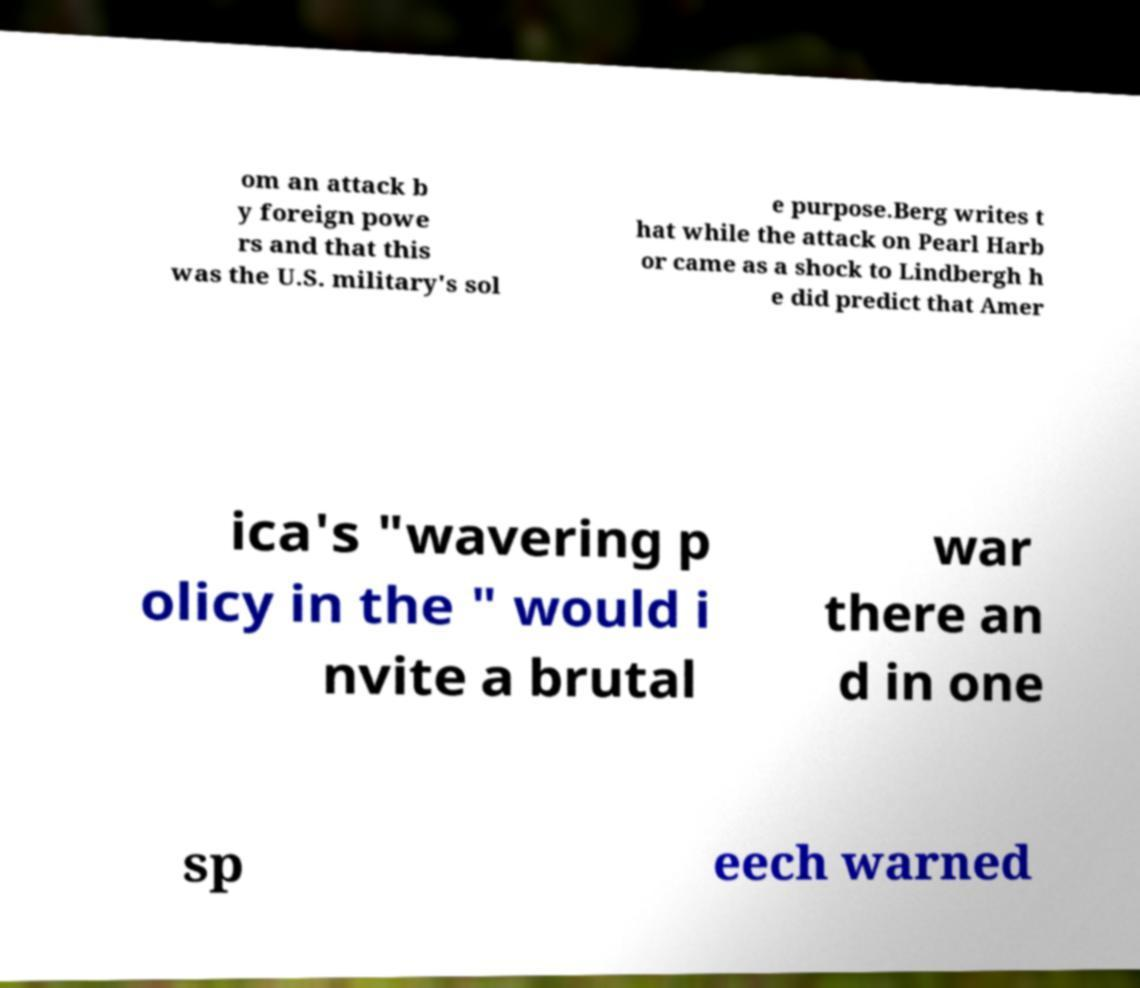What messages or text are displayed in this image? I need them in a readable, typed format. om an attack b y foreign powe rs and that this was the U.S. military's sol e purpose.Berg writes t hat while the attack on Pearl Harb or came as a shock to Lindbergh h e did predict that Amer ica's "wavering p olicy in the " would i nvite a brutal war there an d in one sp eech warned 